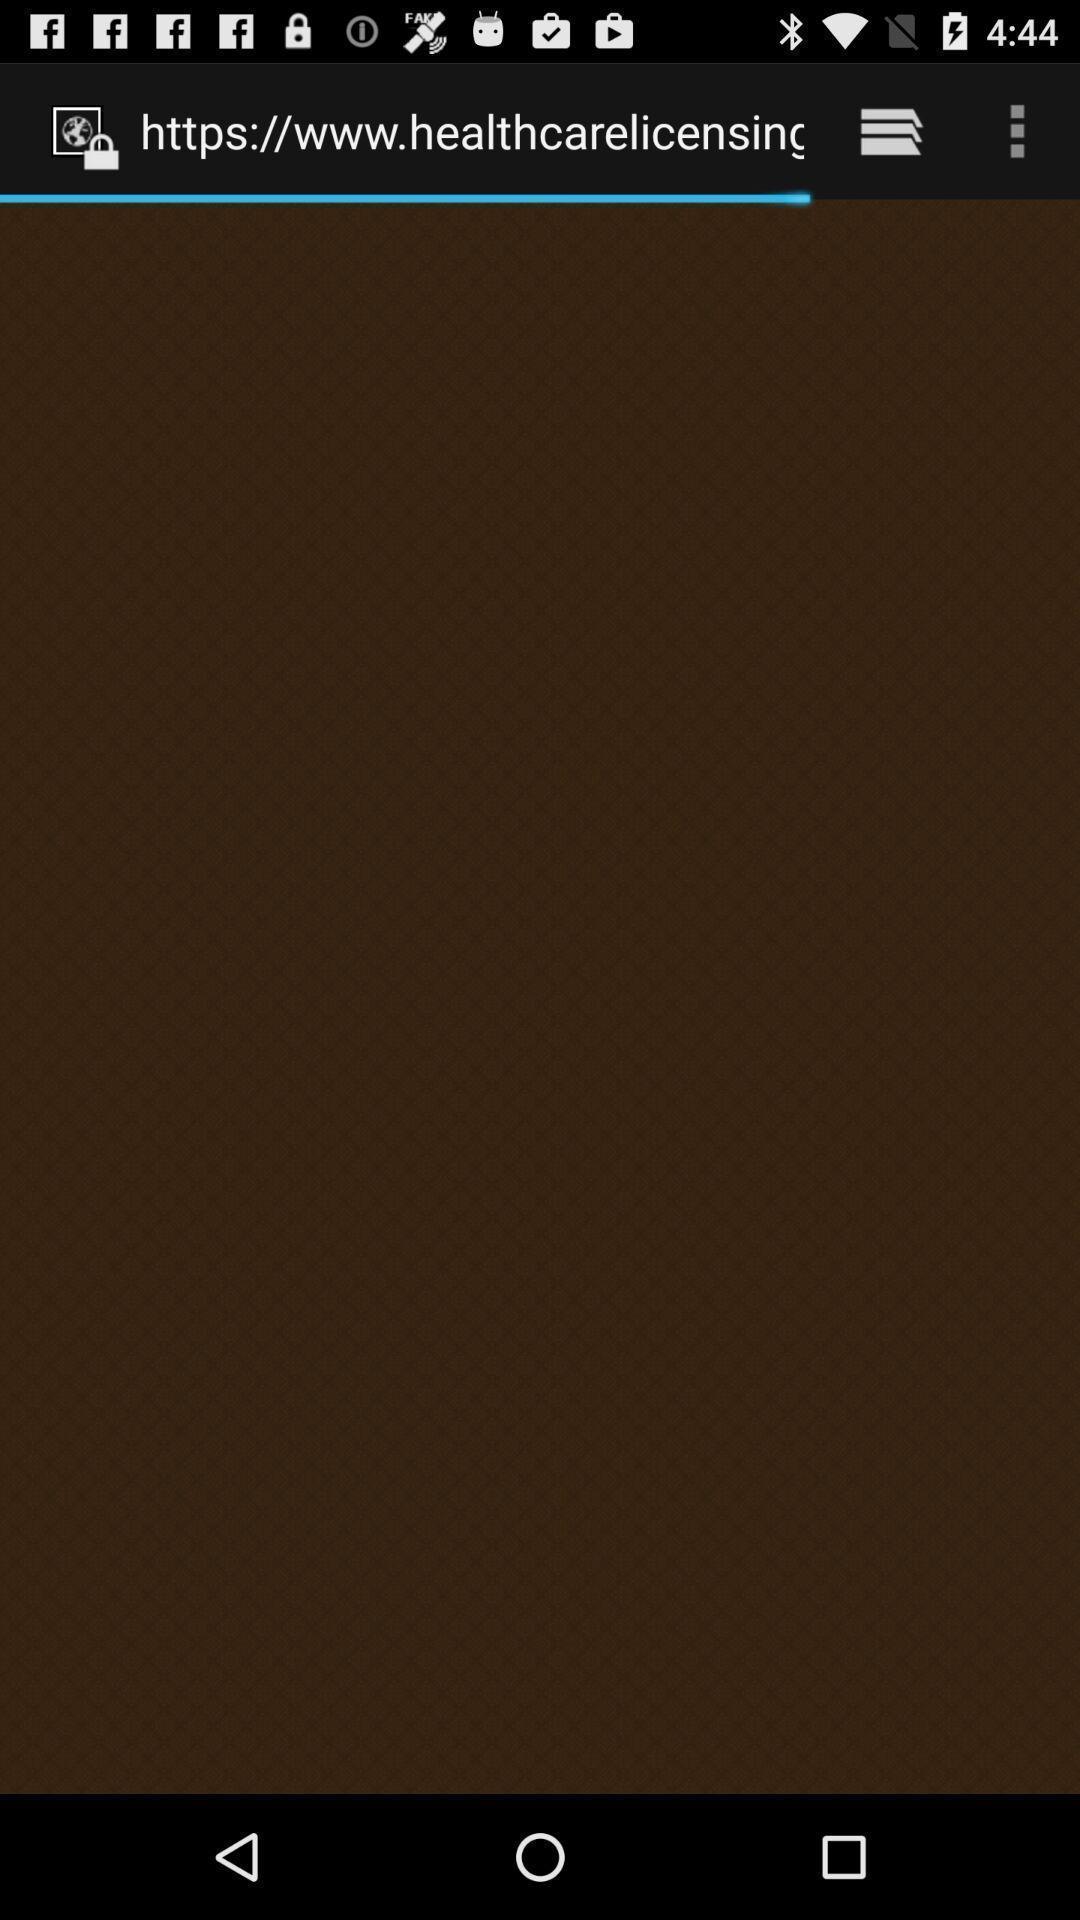Tell me what you see in this picture. Page opening a link on a device. 